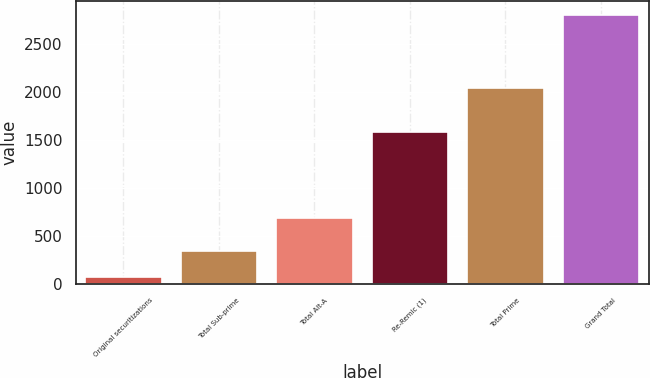Convert chart. <chart><loc_0><loc_0><loc_500><loc_500><bar_chart><fcel>Original securitizations<fcel>Total Sub-prime<fcel>Total Alt-A<fcel>Re-Remic (1)<fcel>Total Prime<fcel>Grand Total<nl><fcel>75<fcel>348.2<fcel>687<fcel>1579<fcel>2043<fcel>2807<nl></chart> 